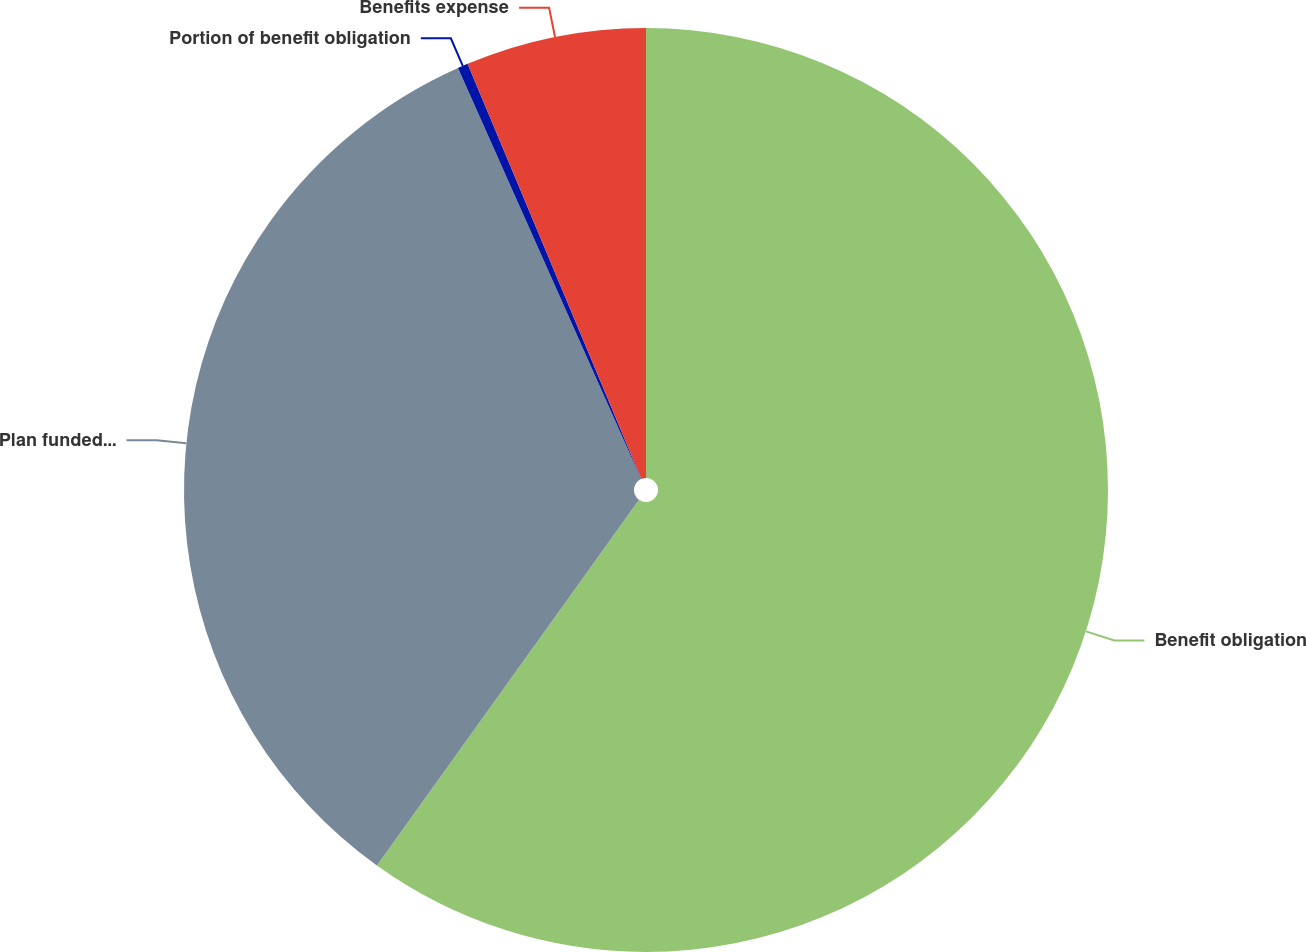<chart> <loc_0><loc_0><loc_500><loc_500><pie_chart><fcel>Benefit obligation<fcel>Plan funded status and<fcel>Portion of benefit obligation<fcel>Benefits expense<nl><fcel>59.89%<fcel>33.43%<fcel>0.36%<fcel>6.31%<nl></chart> 